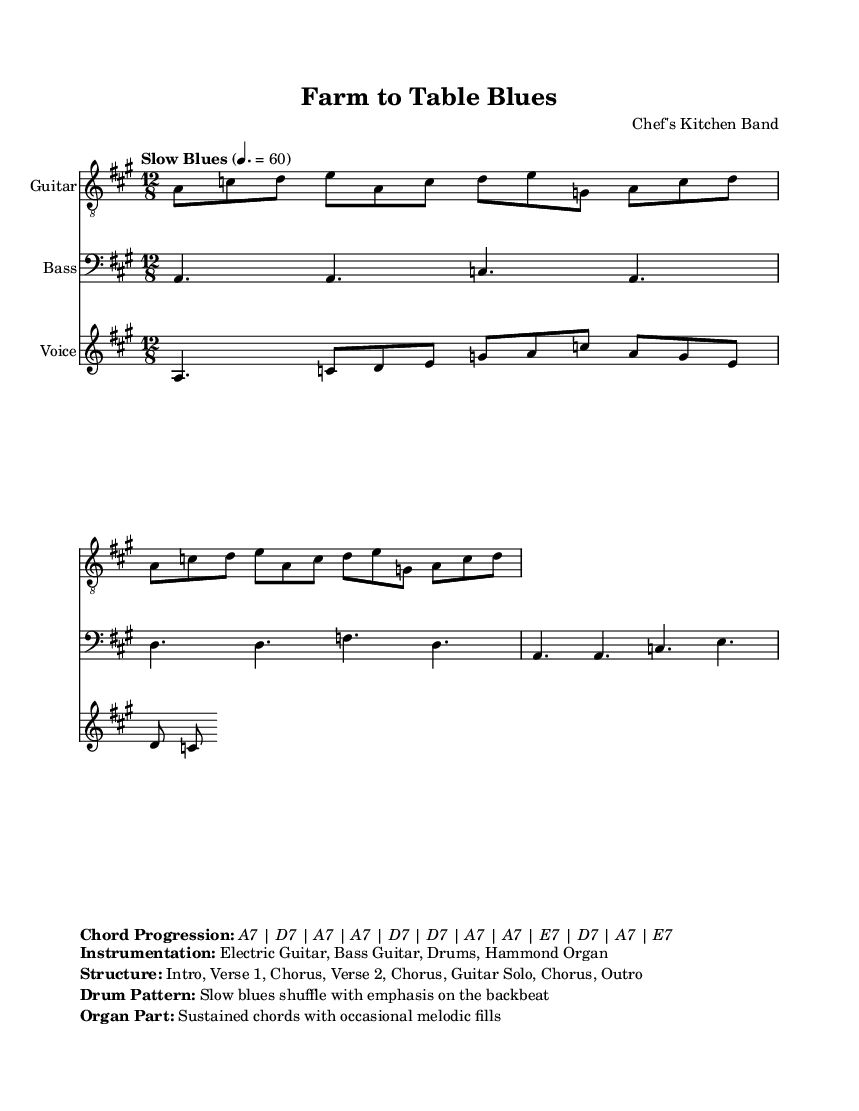What is the key signature of this music? The key signature is A major, indicated by the presence of three sharps (F#, C#, and G#).
Answer: A major What is the time signature of this piece? The time signature shown at the beginning of the sheet music is 12/8, which indicates a compound meter often used in blues.
Answer: 12/8 What is the tempo marking for this music? The tempo marking, which defines the speed of the piece, is indicated as "Slow Blues" at a quarter note equals 60 beats per minute.
Answer: Slow Blues, 4. = 60 How many verses does this song have? There are two verses indicated in the structure of the song, as described in the section detailing the song structure.
Answer: 2 What instruments are included in this piece? The instrumentation is listed clearly as Electric Guitar, Bass Guitar, Drums, and Hammond Organ, showing the ensemble for the performance.
Answer: Electric Guitar, Bass Guitar, Drums, Hammond Organ 